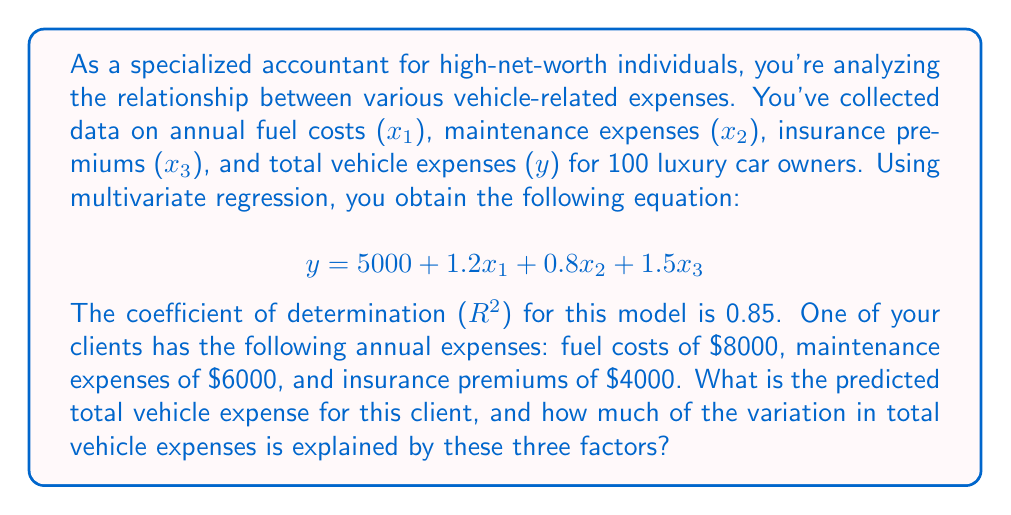Give your solution to this math problem. To solve this problem, we'll follow these steps:

1. Calculate the predicted total vehicle expense using the given regression equation.
2. Interpret the coefficient of determination ($R^2$).

Step 1: Calculating the predicted total vehicle expense

We use the multivariate regression equation:
$$y = 5000 + 1.2x_1 + 0.8x_2 + 1.5x_3$$

Substituting the values for the client:
$x_1 = 8000$ (fuel costs)
$x_2 = 6000$ (maintenance expenses)
$x_3 = 4000$ (insurance premiums)

$$\begin{align*}
y &= 5000 + 1.2(8000) + 0.8(6000) + 1.5(4000) \\
&= 5000 + 9600 + 4800 + 6000 \\
&= 25,400
\end{align*}$$

Step 2: Interpreting the coefficient of determination ($R^2$)

The $R^2$ value is 0.85, which means that 85% of the variation in total vehicle expenses is explained by the three factors (fuel costs, maintenance expenses, and insurance premiums) in our model.

To express this as a percentage, we multiply by 100:
$$0.85 \times 100 = 85\%$$
Answer: The predicted total vehicle expense for the client is $25,400. The three factors (fuel costs, maintenance expenses, and insurance premiums) explain 85% of the variation in total vehicle expenses. 